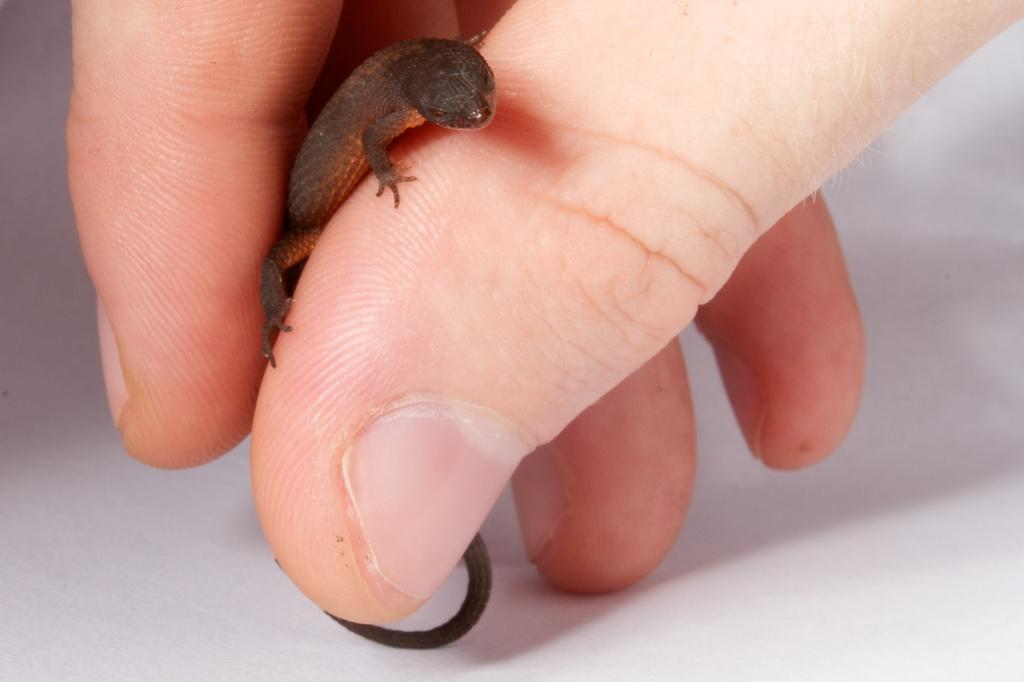What is being held by the hand in the image? The hand is holding a reptile. Can you describe the reptile in the image? The reptile is brown in color. What is the color of the background in the image? The background of the image is white. What type of joke is being told by the reptile in the image? There is no indication in the image that the reptile is telling a joke, as it is simply being held by the hand. 